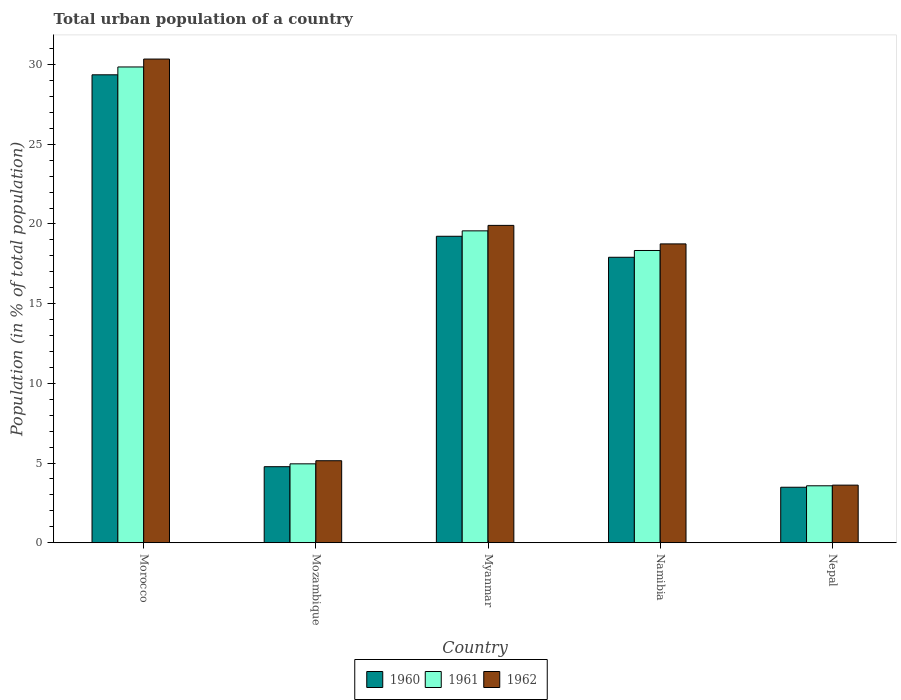How many different coloured bars are there?
Offer a terse response. 3. Are the number of bars per tick equal to the number of legend labels?
Make the answer very short. Yes. Are the number of bars on each tick of the X-axis equal?
Keep it short and to the point. Yes. What is the label of the 3rd group of bars from the left?
Offer a terse response. Myanmar. In how many cases, is the number of bars for a given country not equal to the number of legend labels?
Give a very brief answer. 0. What is the urban population in 1960 in Mozambique?
Provide a short and direct response. 4.77. Across all countries, what is the maximum urban population in 1962?
Keep it short and to the point. 30.34. Across all countries, what is the minimum urban population in 1961?
Your answer should be very brief. 3.57. In which country was the urban population in 1961 maximum?
Provide a succinct answer. Morocco. In which country was the urban population in 1960 minimum?
Your answer should be compact. Nepal. What is the total urban population in 1962 in the graph?
Keep it short and to the point. 77.76. What is the difference between the urban population in 1960 in Morocco and that in Myanmar?
Keep it short and to the point. 10.13. What is the difference between the urban population in 1962 in Morocco and the urban population in 1960 in Mozambique?
Give a very brief answer. 25.58. What is the average urban population in 1961 per country?
Provide a short and direct response. 15.25. What is the difference between the urban population of/in 1961 and urban population of/in 1962 in Mozambique?
Make the answer very short. -0.2. In how many countries, is the urban population in 1962 greater than 4 %?
Your answer should be very brief. 4. What is the ratio of the urban population in 1962 in Myanmar to that in Nepal?
Ensure brevity in your answer.  5.51. What is the difference between the highest and the second highest urban population in 1960?
Your answer should be very brief. -1.32. What is the difference between the highest and the lowest urban population in 1961?
Your answer should be very brief. 26.28. Is the sum of the urban population in 1960 in Mozambique and Myanmar greater than the maximum urban population in 1962 across all countries?
Provide a succinct answer. No. What does the 2nd bar from the right in Myanmar represents?
Ensure brevity in your answer.  1961. Is it the case that in every country, the sum of the urban population in 1960 and urban population in 1961 is greater than the urban population in 1962?
Keep it short and to the point. Yes. How many countries are there in the graph?
Your answer should be very brief. 5. How many legend labels are there?
Your response must be concise. 3. How are the legend labels stacked?
Keep it short and to the point. Horizontal. What is the title of the graph?
Provide a succinct answer. Total urban population of a country. What is the label or title of the X-axis?
Offer a very short reply. Country. What is the label or title of the Y-axis?
Offer a very short reply. Population (in % of total population). What is the Population (in % of total population) in 1960 in Morocco?
Keep it short and to the point. 29.36. What is the Population (in % of total population) in 1961 in Morocco?
Give a very brief answer. 29.85. What is the Population (in % of total population) of 1962 in Morocco?
Make the answer very short. 30.34. What is the Population (in % of total population) of 1960 in Mozambique?
Offer a very short reply. 4.77. What is the Population (in % of total population) in 1961 in Mozambique?
Keep it short and to the point. 4.95. What is the Population (in % of total population) in 1962 in Mozambique?
Offer a terse response. 5.14. What is the Population (in % of total population) in 1960 in Myanmar?
Offer a very short reply. 19.23. What is the Population (in % of total population) of 1961 in Myanmar?
Give a very brief answer. 19.57. What is the Population (in % of total population) of 1962 in Myanmar?
Offer a terse response. 19.91. What is the Population (in % of total population) of 1960 in Namibia?
Your response must be concise. 17.91. What is the Population (in % of total population) in 1961 in Namibia?
Give a very brief answer. 18.33. What is the Population (in % of total population) of 1962 in Namibia?
Provide a succinct answer. 18.75. What is the Population (in % of total population) of 1960 in Nepal?
Provide a short and direct response. 3.48. What is the Population (in % of total population) in 1961 in Nepal?
Give a very brief answer. 3.57. What is the Population (in % of total population) of 1962 in Nepal?
Your response must be concise. 3.61. Across all countries, what is the maximum Population (in % of total population) in 1960?
Provide a short and direct response. 29.36. Across all countries, what is the maximum Population (in % of total population) of 1961?
Give a very brief answer. 29.85. Across all countries, what is the maximum Population (in % of total population) in 1962?
Provide a short and direct response. 30.34. Across all countries, what is the minimum Population (in % of total population) of 1960?
Provide a short and direct response. 3.48. Across all countries, what is the minimum Population (in % of total population) of 1961?
Offer a terse response. 3.57. Across all countries, what is the minimum Population (in % of total population) in 1962?
Make the answer very short. 3.61. What is the total Population (in % of total population) of 1960 in the graph?
Ensure brevity in your answer.  74.74. What is the total Population (in % of total population) in 1961 in the graph?
Your answer should be compact. 76.27. What is the total Population (in % of total population) of 1962 in the graph?
Ensure brevity in your answer.  77.76. What is the difference between the Population (in % of total population) of 1960 in Morocco and that in Mozambique?
Provide a succinct answer. 24.59. What is the difference between the Population (in % of total population) in 1961 in Morocco and that in Mozambique?
Ensure brevity in your answer.  24.9. What is the difference between the Population (in % of total population) of 1962 in Morocco and that in Mozambique?
Offer a terse response. 25.2. What is the difference between the Population (in % of total population) in 1960 in Morocco and that in Myanmar?
Give a very brief answer. 10.13. What is the difference between the Population (in % of total population) in 1961 in Morocco and that in Myanmar?
Your response must be concise. 10.28. What is the difference between the Population (in % of total population) in 1962 in Morocco and that in Myanmar?
Your response must be concise. 10.44. What is the difference between the Population (in % of total population) in 1960 in Morocco and that in Namibia?
Keep it short and to the point. 11.45. What is the difference between the Population (in % of total population) in 1961 in Morocco and that in Namibia?
Give a very brief answer. 11.52. What is the difference between the Population (in % of total population) in 1962 in Morocco and that in Namibia?
Give a very brief answer. 11.6. What is the difference between the Population (in % of total population) of 1960 in Morocco and that in Nepal?
Provide a succinct answer. 25.88. What is the difference between the Population (in % of total population) of 1961 in Morocco and that in Nepal?
Offer a terse response. 26.28. What is the difference between the Population (in % of total population) of 1962 in Morocco and that in Nepal?
Offer a very short reply. 26.73. What is the difference between the Population (in % of total population) of 1960 in Mozambique and that in Myanmar?
Offer a terse response. -14.46. What is the difference between the Population (in % of total population) in 1961 in Mozambique and that in Myanmar?
Your answer should be very brief. -14.62. What is the difference between the Population (in % of total population) of 1962 in Mozambique and that in Myanmar?
Ensure brevity in your answer.  -14.77. What is the difference between the Population (in % of total population) in 1960 in Mozambique and that in Namibia?
Give a very brief answer. -13.14. What is the difference between the Population (in % of total population) in 1961 in Mozambique and that in Namibia?
Your response must be concise. -13.38. What is the difference between the Population (in % of total population) of 1962 in Mozambique and that in Namibia?
Keep it short and to the point. -13.6. What is the difference between the Population (in % of total population) of 1960 in Mozambique and that in Nepal?
Your answer should be very brief. 1.29. What is the difference between the Population (in % of total population) in 1961 in Mozambique and that in Nepal?
Make the answer very short. 1.38. What is the difference between the Population (in % of total population) in 1962 in Mozambique and that in Nepal?
Offer a very short reply. 1.53. What is the difference between the Population (in % of total population) in 1960 in Myanmar and that in Namibia?
Offer a terse response. 1.32. What is the difference between the Population (in % of total population) in 1961 in Myanmar and that in Namibia?
Offer a very short reply. 1.23. What is the difference between the Population (in % of total population) in 1962 in Myanmar and that in Namibia?
Your response must be concise. 1.16. What is the difference between the Population (in % of total population) in 1960 in Myanmar and that in Nepal?
Provide a succinct answer. 15.75. What is the difference between the Population (in % of total population) of 1961 in Myanmar and that in Nepal?
Your answer should be very brief. 15.99. What is the difference between the Population (in % of total population) of 1962 in Myanmar and that in Nepal?
Offer a very short reply. 16.3. What is the difference between the Population (in % of total population) of 1960 in Namibia and that in Nepal?
Provide a short and direct response. 14.43. What is the difference between the Population (in % of total population) of 1961 in Namibia and that in Nepal?
Give a very brief answer. 14.76. What is the difference between the Population (in % of total population) of 1962 in Namibia and that in Nepal?
Your response must be concise. 15.14. What is the difference between the Population (in % of total population) of 1960 in Morocco and the Population (in % of total population) of 1961 in Mozambique?
Give a very brief answer. 24.41. What is the difference between the Population (in % of total population) in 1960 in Morocco and the Population (in % of total population) in 1962 in Mozambique?
Ensure brevity in your answer.  24.21. What is the difference between the Population (in % of total population) of 1961 in Morocco and the Population (in % of total population) of 1962 in Mozambique?
Provide a succinct answer. 24.7. What is the difference between the Population (in % of total population) of 1960 in Morocco and the Population (in % of total population) of 1961 in Myanmar?
Your answer should be very brief. 9.79. What is the difference between the Population (in % of total population) in 1960 in Morocco and the Population (in % of total population) in 1962 in Myanmar?
Your response must be concise. 9.45. What is the difference between the Population (in % of total population) in 1961 in Morocco and the Population (in % of total population) in 1962 in Myanmar?
Give a very brief answer. 9.94. What is the difference between the Population (in % of total population) of 1960 in Morocco and the Population (in % of total population) of 1961 in Namibia?
Keep it short and to the point. 11.02. What is the difference between the Population (in % of total population) of 1960 in Morocco and the Population (in % of total population) of 1962 in Namibia?
Your answer should be very brief. 10.61. What is the difference between the Population (in % of total population) in 1961 in Morocco and the Population (in % of total population) in 1962 in Namibia?
Your response must be concise. 11.1. What is the difference between the Population (in % of total population) of 1960 in Morocco and the Population (in % of total population) of 1961 in Nepal?
Your answer should be compact. 25.79. What is the difference between the Population (in % of total population) in 1960 in Morocco and the Population (in % of total population) in 1962 in Nepal?
Offer a very short reply. 25.75. What is the difference between the Population (in % of total population) of 1961 in Morocco and the Population (in % of total population) of 1962 in Nepal?
Your answer should be very brief. 26.24. What is the difference between the Population (in % of total population) in 1960 in Mozambique and the Population (in % of total population) in 1961 in Myanmar?
Offer a very short reply. -14.8. What is the difference between the Population (in % of total population) of 1960 in Mozambique and the Population (in % of total population) of 1962 in Myanmar?
Your response must be concise. -15.14. What is the difference between the Population (in % of total population) of 1961 in Mozambique and the Population (in % of total population) of 1962 in Myanmar?
Offer a terse response. -14.96. What is the difference between the Population (in % of total population) in 1960 in Mozambique and the Population (in % of total population) in 1961 in Namibia?
Your answer should be very brief. -13.56. What is the difference between the Population (in % of total population) of 1960 in Mozambique and the Population (in % of total population) of 1962 in Namibia?
Provide a succinct answer. -13.98. What is the difference between the Population (in % of total population) of 1961 in Mozambique and the Population (in % of total population) of 1962 in Namibia?
Make the answer very short. -13.8. What is the difference between the Population (in % of total population) in 1960 in Mozambique and the Population (in % of total population) in 1961 in Nepal?
Offer a terse response. 1.2. What is the difference between the Population (in % of total population) in 1960 in Mozambique and the Population (in % of total population) in 1962 in Nepal?
Give a very brief answer. 1.16. What is the difference between the Population (in % of total population) of 1961 in Mozambique and the Population (in % of total population) of 1962 in Nepal?
Keep it short and to the point. 1.34. What is the difference between the Population (in % of total population) in 1960 in Myanmar and the Population (in % of total population) in 1961 in Namibia?
Provide a succinct answer. 0.89. What is the difference between the Population (in % of total population) in 1960 in Myanmar and the Population (in % of total population) in 1962 in Namibia?
Your answer should be very brief. 0.48. What is the difference between the Population (in % of total population) in 1961 in Myanmar and the Population (in % of total population) in 1962 in Namibia?
Offer a very short reply. 0.82. What is the difference between the Population (in % of total population) in 1960 in Myanmar and the Population (in % of total population) in 1961 in Nepal?
Ensure brevity in your answer.  15.65. What is the difference between the Population (in % of total population) of 1960 in Myanmar and the Population (in % of total population) of 1962 in Nepal?
Offer a terse response. 15.61. What is the difference between the Population (in % of total population) of 1961 in Myanmar and the Population (in % of total population) of 1962 in Nepal?
Make the answer very short. 15.95. What is the difference between the Population (in % of total population) of 1960 in Namibia and the Population (in % of total population) of 1961 in Nepal?
Ensure brevity in your answer.  14.34. What is the difference between the Population (in % of total population) of 1960 in Namibia and the Population (in % of total population) of 1962 in Nepal?
Make the answer very short. 14.3. What is the difference between the Population (in % of total population) of 1961 in Namibia and the Population (in % of total population) of 1962 in Nepal?
Your response must be concise. 14.72. What is the average Population (in % of total population) in 1960 per country?
Provide a short and direct response. 14.95. What is the average Population (in % of total population) of 1961 per country?
Your response must be concise. 15.25. What is the average Population (in % of total population) in 1962 per country?
Provide a short and direct response. 15.55. What is the difference between the Population (in % of total population) of 1960 and Population (in % of total population) of 1961 in Morocco?
Provide a short and direct response. -0.49. What is the difference between the Population (in % of total population) of 1960 and Population (in % of total population) of 1962 in Morocco?
Provide a short and direct response. -0.99. What is the difference between the Population (in % of total population) of 1961 and Population (in % of total population) of 1962 in Morocco?
Offer a very short reply. -0.5. What is the difference between the Population (in % of total population) of 1960 and Population (in % of total population) of 1961 in Mozambique?
Your answer should be compact. -0.18. What is the difference between the Population (in % of total population) of 1960 and Population (in % of total population) of 1962 in Mozambique?
Ensure brevity in your answer.  -0.38. What is the difference between the Population (in % of total population) of 1961 and Population (in % of total population) of 1962 in Mozambique?
Give a very brief answer. -0.2. What is the difference between the Population (in % of total population) in 1960 and Population (in % of total population) in 1961 in Myanmar?
Provide a succinct answer. -0.34. What is the difference between the Population (in % of total population) of 1960 and Population (in % of total population) of 1962 in Myanmar?
Offer a very short reply. -0.68. What is the difference between the Population (in % of total population) of 1961 and Population (in % of total population) of 1962 in Myanmar?
Make the answer very short. -0.34. What is the difference between the Population (in % of total population) of 1960 and Population (in % of total population) of 1961 in Namibia?
Ensure brevity in your answer.  -0.42. What is the difference between the Population (in % of total population) of 1960 and Population (in % of total population) of 1962 in Namibia?
Your response must be concise. -0.84. What is the difference between the Population (in % of total population) in 1961 and Population (in % of total population) in 1962 in Namibia?
Offer a very short reply. -0.41. What is the difference between the Population (in % of total population) in 1960 and Population (in % of total population) in 1961 in Nepal?
Offer a very short reply. -0.09. What is the difference between the Population (in % of total population) in 1960 and Population (in % of total population) in 1962 in Nepal?
Ensure brevity in your answer.  -0.13. What is the difference between the Population (in % of total population) in 1961 and Population (in % of total population) in 1962 in Nepal?
Your answer should be very brief. -0.04. What is the ratio of the Population (in % of total population) in 1960 in Morocco to that in Mozambique?
Make the answer very short. 6.16. What is the ratio of the Population (in % of total population) of 1961 in Morocco to that in Mozambique?
Make the answer very short. 6.03. What is the ratio of the Population (in % of total population) in 1962 in Morocco to that in Mozambique?
Offer a very short reply. 5.9. What is the ratio of the Population (in % of total population) in 1960 in Morocco to that in Myanmar?
Keep it short and to the point. 1.53. What is the ratio of the Population (in % of total population) of 1961 in Morocco to that in Myanmar?
Your response must be concise. 1.53. What is the ratio of the Population (in % of total population) in 1962 in Morocco to that in Myanmar?
Give a very brief answer. 1.52. What is the ratio of the Population (in % of total population) in 1960 in Morocco to that in Namibia?
Ensure brevity in your answer.  1.64. What is the ratio of the Population (in % of total population) of 1961 in Morocco to that in Namibia?
Your response must be concise. 1.63. What is the ratio of the Population (in % of total population) in 1962 in Morocco to that in Namibia?
Your response must be concise. 1.62. What is the ratio of the Population (in % of total population) in 1960 in Morocco to that in Nepal?
Offer a terse response. 8.44. What is the ratio of the Population (in % of total population) in 1961 in Morocco to that in Nepal?
Your response must be concise. 8.36. What is the ratio of the Population (in % of total population) of 1962 in Morocco to that in Nepal?
Your response must be concise. 8.4. What is the ratio of the Population (in % of total population) of 1960 in Mozambique to that in Myanmar?
Your response must be concise. 0.25. What is the ratio of the Population (in % of total population) of 1961 in Mozambique to that in Myanmar?
Give a very brief answer. 0.25. What is the ratio of the Population (in % of total population) of 1962 in Mozambique to that in Myanmar?
Your answer should be very brief. 0.26. What is the ratio of the Population (in % of total population) in 1960 in Mozambique to that in Namibia?
Your answer should be compact. 0.27. What is the ratio of the Population (in % of total population) in 1961 in Mozambique to that in Namibia?
Your answer should be very brief. 0.27. What is the ratio of the Population (in % of total population) in 1962 in Mozambique to that in Namibia?
Keep it short and to the point. 0.27. What is the ratio of the Population (in % of total population) in 1960 in Mozambique to that in Nepal?
Offer a very short reply. 1.37. What is the ratio of the Population (in % of total population) in 1961 in Mozambique to that in Nepal?
Provide a short and direct response. 1.39. What is the ratio of the Population (in % of total population) in 1962 in Mozambique to that in Nepal?
Offer a terse response. 1.42. What is the ratio of the Population (in % of total population) of 1960 in Myanmar to that in Namibia?
Keep it short and to the point. 1.07. What is the ratio of the Population (in % of total population) in 1961 in Myanmar to that in Namibia?
Offer a very short reply. 1.07. What is the ratio of the Population (in % of total population) of 1962 in Myanmar to that in Namibia?
Ensure brevity in your answer.  1.06. What is the ratio of the Population (in % of total population) of 1960 in Myanmar to that in Nepal?
Make the answer very short. 5.52. What is the ratio of the Population (in % of total population) in 1961 in Myanmar to that in Nepal?
Your answer should be very brief. 5.48. What is the ratio of the Population (in % of total population) in 1962 in Myanmar to that in Nepal?
Offer a terse response. 5.51. What is the ratio of the Population (in % of total population) of 1960 in Namibia to that in Nepal?
Your response must be concise. 5.15. What is the ratio of the Population (in % of total population) of 1961 in Namibia to that in Nepal?
Offer a very short reply. 5.13. What is the ratio of the Population (in % of total population) in 1962 in Namibia to that in Nepal?
Give a very brief answer. 5.19. What is the difference between the highest and the second highest Population (in % of total population) of 1960?
Make the answer very short. 10.13. What is the difference between the highest and the second highest Population (in % of total population) in 1961?
Provide a succinct answer. 10.28. What is the difference between the highest and the second highest Population (in % of total population) of 1962?
Your response must be concise. 10.44. What is the difference between the highest and the lowest Population (in % of total population) in 1960?
Provide a short and direct response. 25.88. What is the difference between the highest and the lowest Population (in % of total population) of 1961?
Offer a terse response. 26.28. What is the difference between the highest and the lowest Population (in % of total population) in 1962?
Your answer should be very brief. 26.73. 